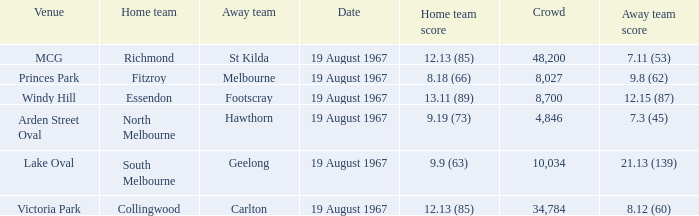When the venue was lake oval what did the home team score? 9.9 (63). 